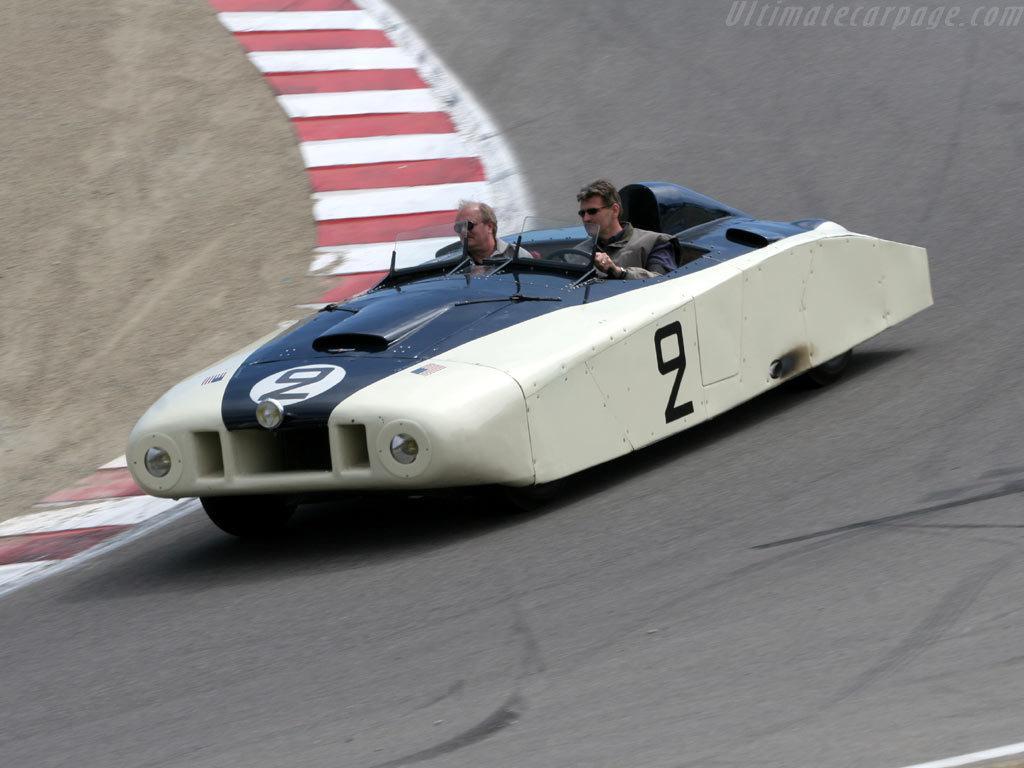In one or two sentences, can you explain what this image depicts? In the center of the image we can see one vehicle on the road. And we can see two persons sitting in the vehicle. On the top right side of the image, there is a watermark. 